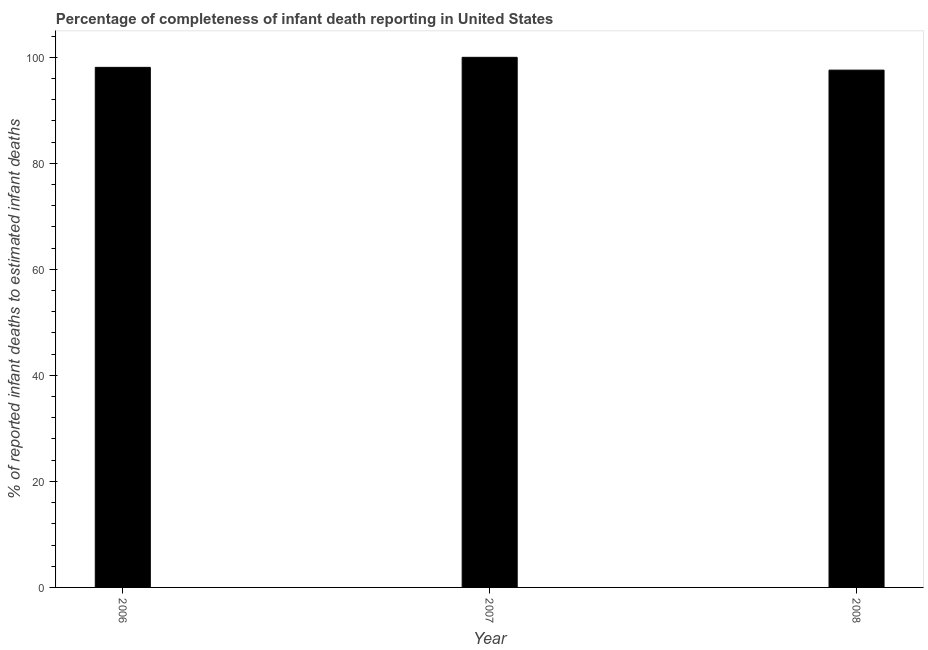What is the title of the graph?
Offer a terse response. Percentage of completeness of infant death reporting in United States. What is the label or title of the Y-axis?
Your response must be concise. % of reported infant deaths to estimated infant deaths. Across all years, what is the maximum completeness of infant death reporting?
Your answer should be compact. 100. Across all years, what is the minimum completeness of infant death reporting?
Provide a succinct answer. 97.58. In which year was the completeness of infant death reporting maximum?
Keep it short and to the point. 2007. What is the sum of the completeness of infant death reporting?
Provide a short and direct response. 295.69. What is the difference between the completeness of infant death reporting in 2007 and 2008?
Keep it short and to the point. 2.42. What is the average completeness of infant death reporting per year?
Ensure brevity in your answer.  98.56. What is the median completeness of infant death reporting?
Your answer should be compact. 98.11. In how many years, is the completeness of infant death reporting greater than 60 %?
Your answer should be compact. 3. Is the completeness of infant death reporting in 2006 less than that in 2008?
Make the answer very short. No. What is the difference between the highest and the second highest completeness of infant death reporting?
Your response must be concise. 1.89. Is the sum of the completeness of infant death reporting in 2006 and 2007 greater than the maximum completeness of infant death reporting across all years?
Your response must be concise. Yes. What is the difference between the highest and the lowest completeness of infant death reporting?
Your answer should be compact. 2.42. How many bars are there?
Make the answer very short. 3. Are all the bars in the graph horizontal?
Make the answer very short. No. What is the difference between two consecutive major ticks on the Y-axis?
Provide a succinct answer. 20. Are the values on the major ticks of Y-axis written in scientific E-notation?
Offer a very short reply. No. What is the % of reported infant deaths to estimated infant deaths in 2006?
Offer a terse response. 98.11. What is the % of reported infant deaths to estimated infant deaths in 2008?
Make the answer very short. 97.58. What is the difference between the % of reported infant deaths to estimated infant deaths in 2006 and 2007?
Give a very brief answer. -1.89. What is the difference between the % of reported infant deaths to estimated infant deaths in 2006 and 2008?
Offer a terse response. 0.52. What is the difference between the % of reported infant deaths to estimated infant deaths in 2007 and 2008?
Make the answer very short. 2.42. What is the ratio of the % of reported infant deaths to estimated infant deaths in 2006 to that in 2007?
Ensure brevity in your answer.  0.98. What is the ratio of the % of reported infant deaths to estimated infant deaths in 2006 to that in 2008?
Keep it short and to the point. 1. 